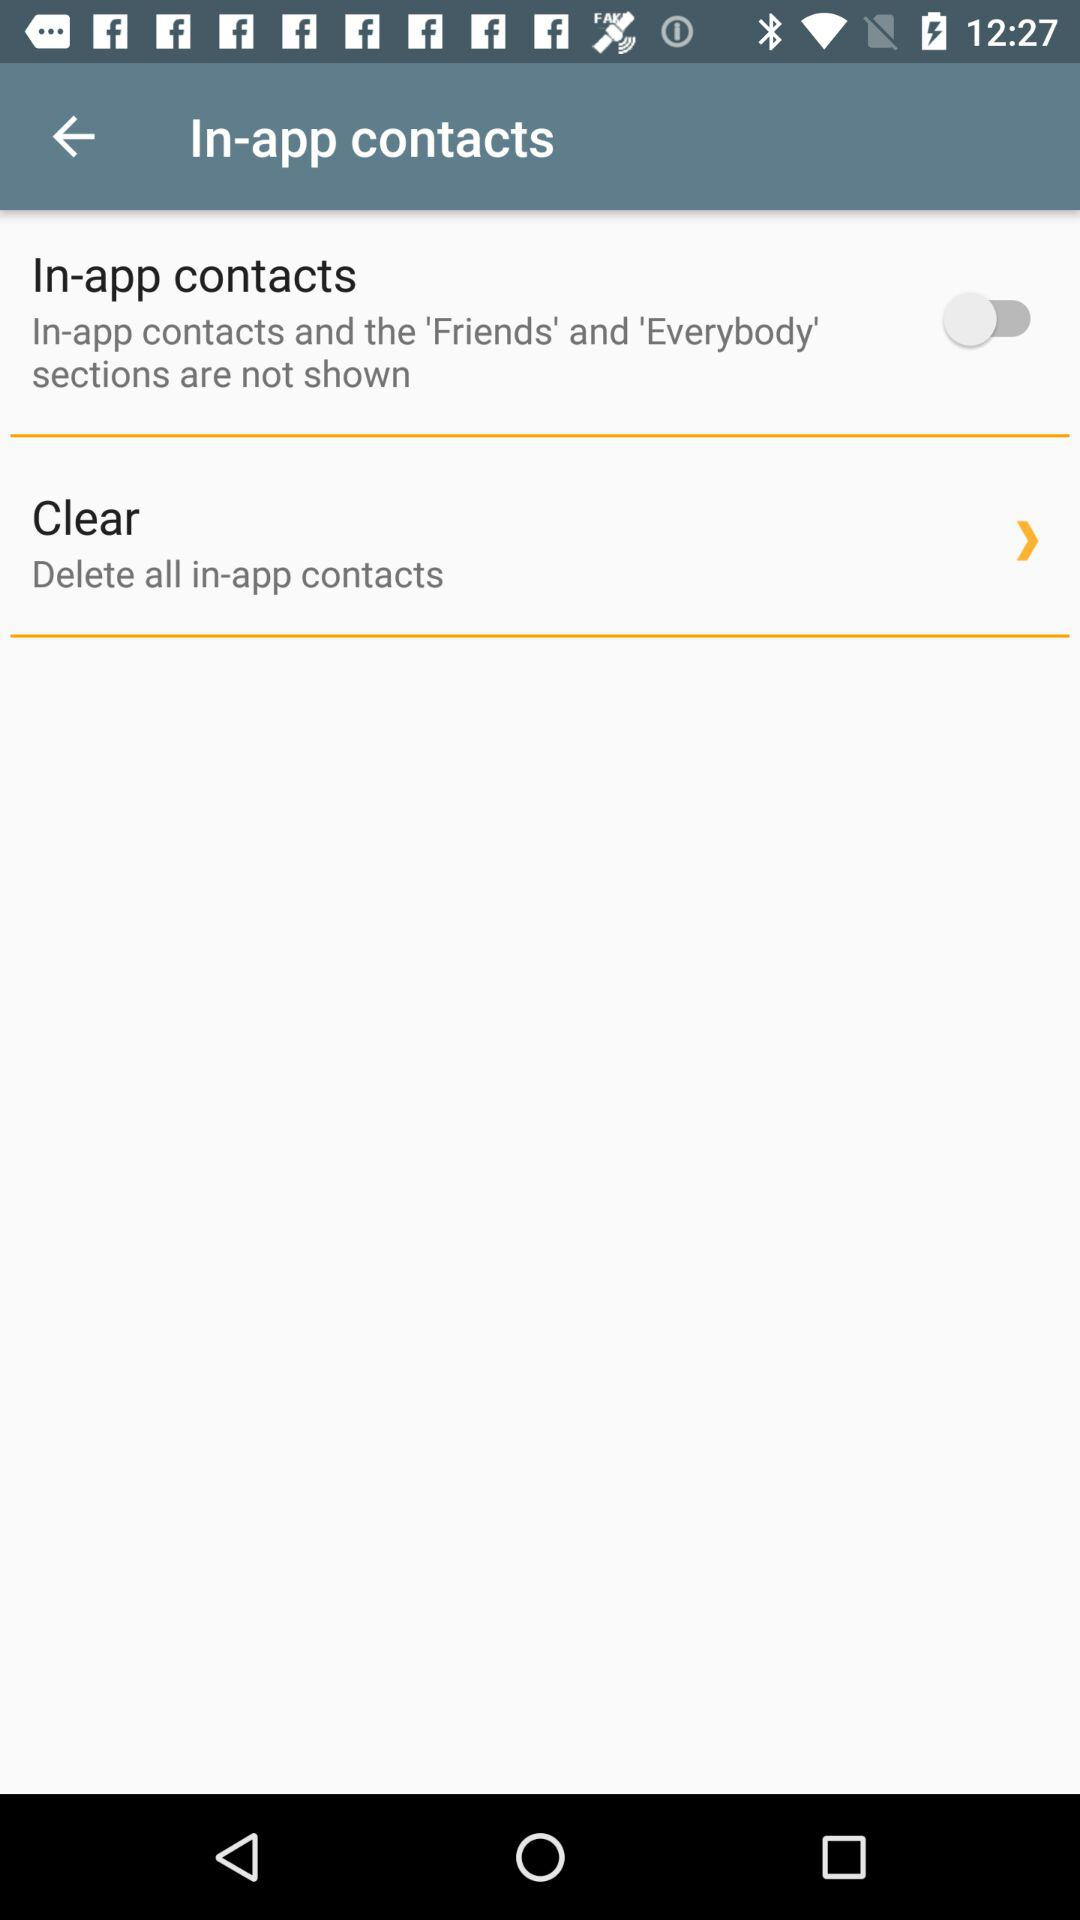What is the status of "In-app contacts"? The status of "In-App contacts" is off. 